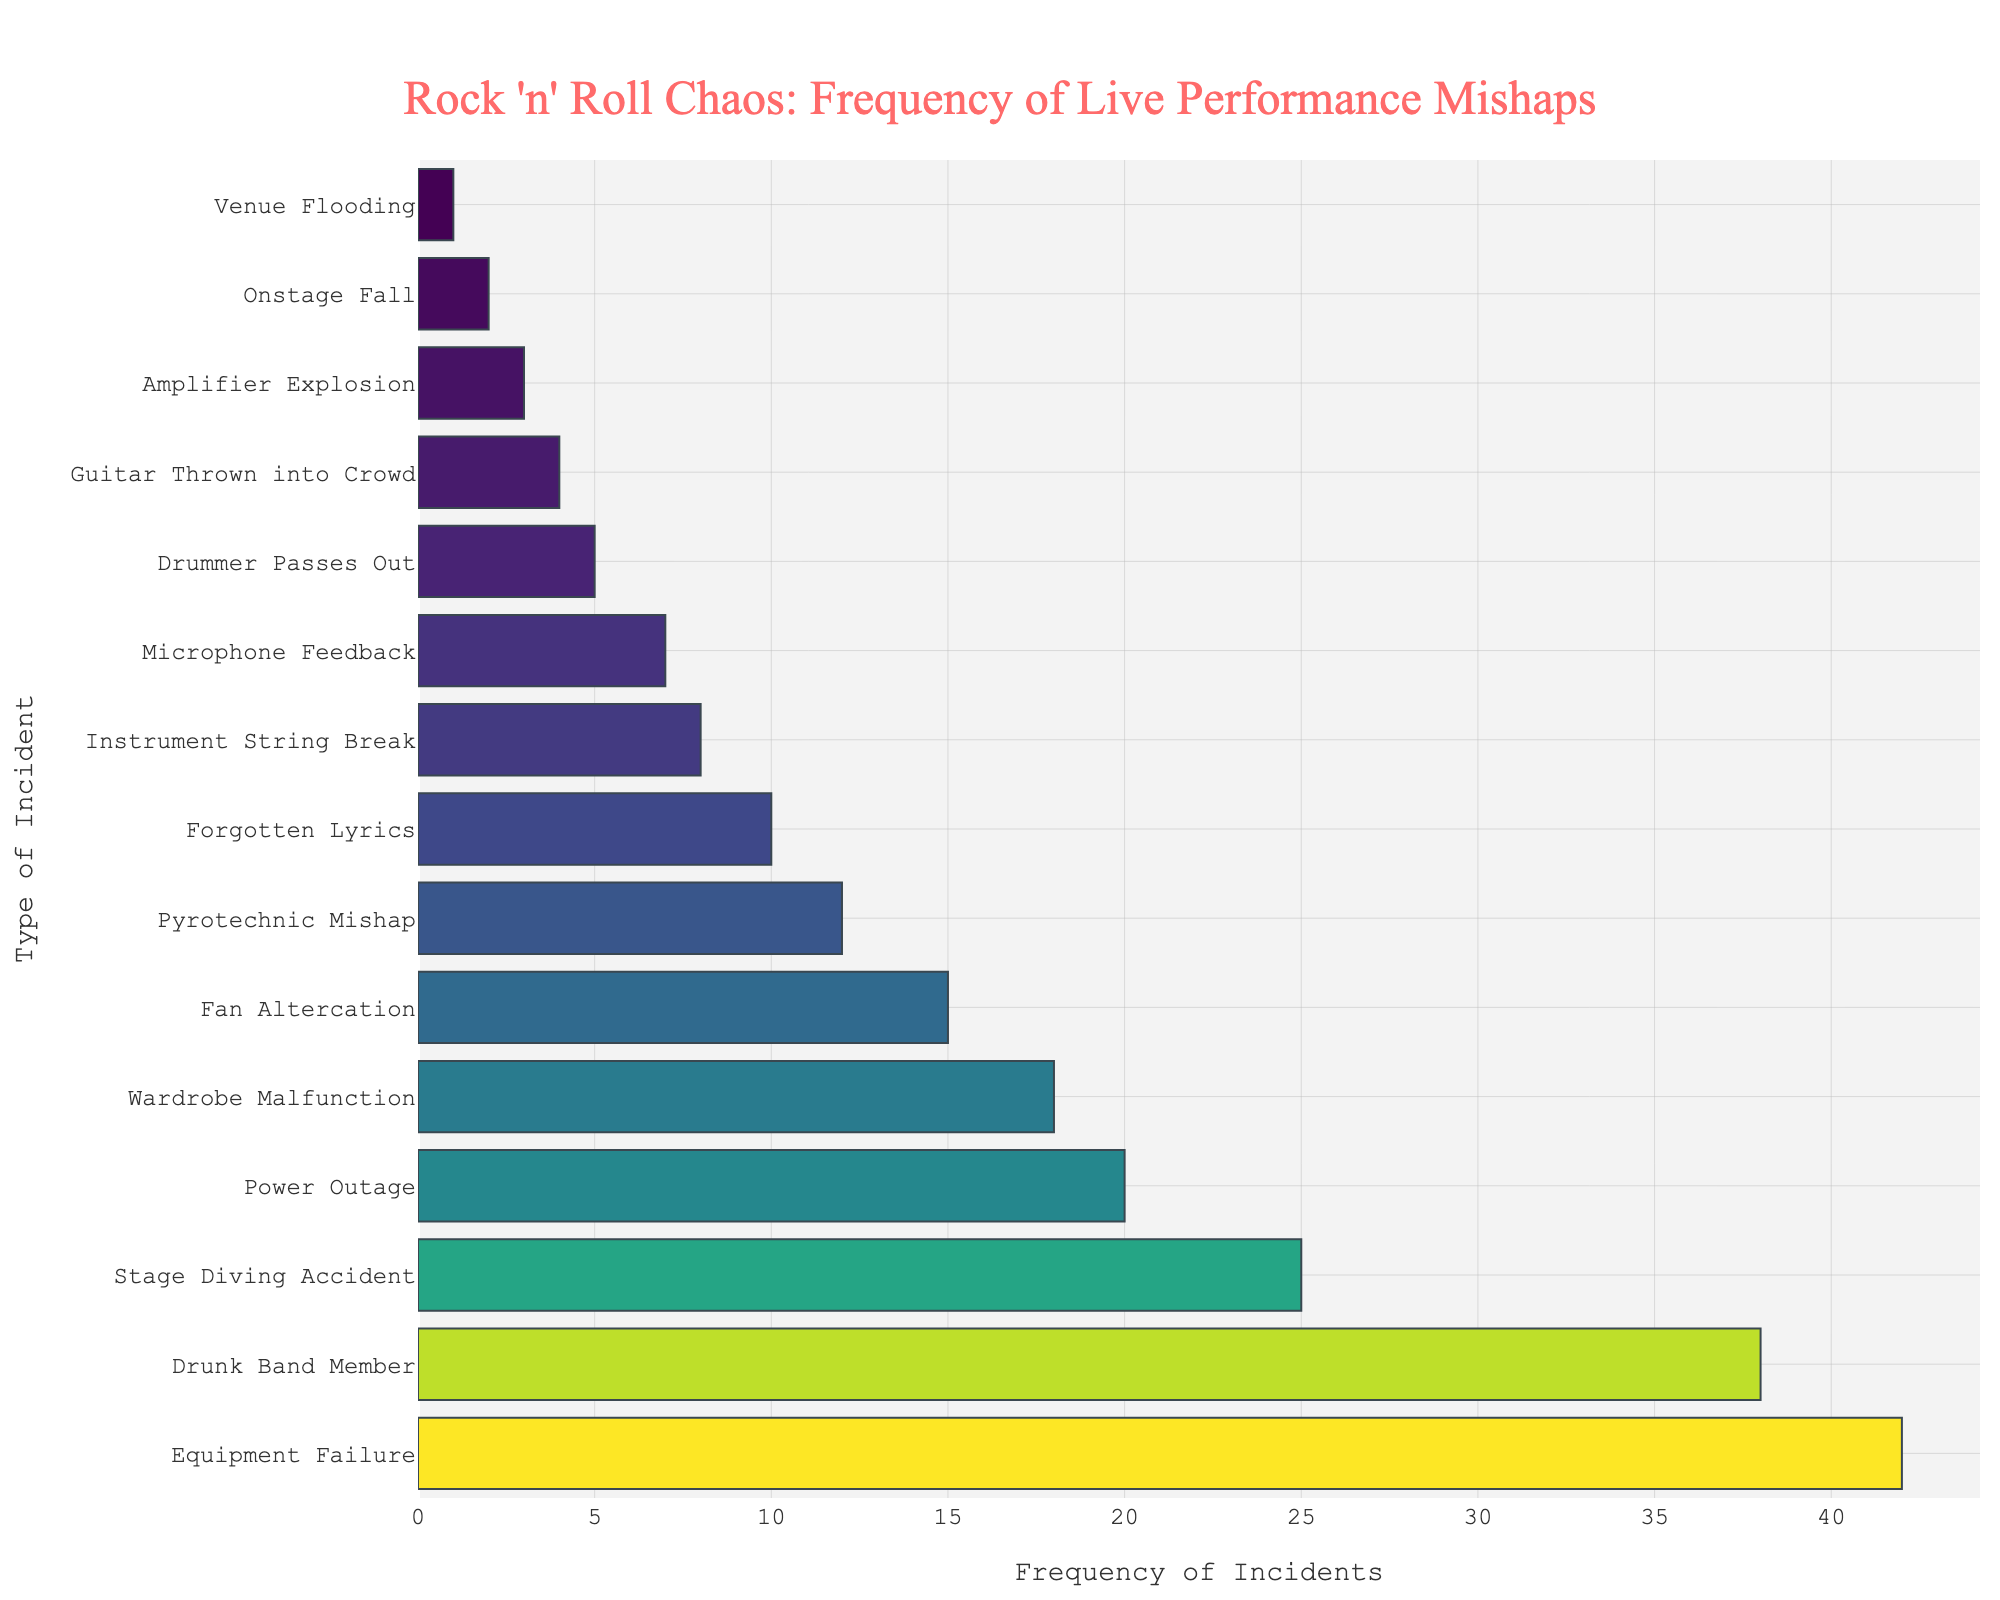What's the most frequent type of incident during live performances? To find the most frequent type of incident, look for the bar with the highest value. In this case, the "Equipment Failure" bar is the tallest and has a frequency of 42.
Answer: Equipment Failure Which type of incident has a frequency of 25? To identify the incident with a frequency of 25, find the bar that aligns with this frequency value. The "Stage Diving Accident" bar corresponds to a frequency of 25.
Answer: Stage Diving Accident How many more incidents of "Drunk Band Member" are there than "Forgotten Lyrics"? Compare the frequencies of "Drunk Band Member" (38) and "Forgotten Lyrics" (10). Subtract the smaller frequency from the larger one: 38 - 10 = 28.
Answer: 28 What's the total frequency of incidents related to equipment issues (Equipment Failure and Amplifier Explosion)? Sum the frequencies of "Equipment Failure" (42) and "Amplifier Explosion" (3): 42 + 3 = 45.
Answer: 45 Which incident has the lowest frequency? The incident with the lowest frequency will have the shortest bar. "Venue Flooding" has a frequency of 1, making it the lowest.
Answer: Venue Flooding Between "Wardrobe Malfunction" and "Pyrotechnic Mishap," which is more frequent? Compare the heights of the bars for "Wardrobe Malfunction" (18) and "Pyrotechnic Mishap" (12). "Wardrobe Malfunction" is more frequent.
Answer: Wardrobe Malfunction What is the combined frequency of incidents involving fans (Stage Diving Accident, Fan Altercation)? Add the frequencies of "Stage Diving Accident" (25) and "Fan Altercation" (15): 25 + 15 = 40.
Answer: 40 How does the frequency of "Drummer Passes Out" compare to "Guitar Thrown into Crowd"? Compare the frequencies of "Drummer Passes Out" (5) and "Guitar Thrown into Crowd" (4). "Drummer Passes Out" has a higher frequency.
Answer: Drummer Passes Out What is the total frequency of all incidents with a frequency below 10? Identify and sum all incidents with frequencies below 10: "Instrument String Break" (8), "Microphone Feedback" (7), "Drummer Passes Out" (5), "Guitar Thrown into Crowd" (4), "Amplifier Explosion" (3), "Onstage Fall" (2), and "Venue Flooding" (1). Total is 8 + 7 + 5 + 4 + 3 + 2 + 1 = 30.
Answer: 30 Find the median frequency of all incidents. Rank the frequencies from lowest to highest: [1, 2, 3, 4, 5, 7, 8, 10, 12, 15, 18, 20, 25, 38, 42]. The median is the middle value in this ordered list, which is 10 (since there are 15 values).
Answer: 10 